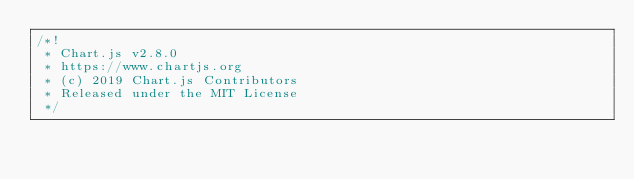<code> <loc_0><loc_0><loc_500><loc_500><_JavaScript_>/*!
 * Chart.js v2.8.0
 * https://www.chartjs.org
 * (c) 2019 Chart.js Contributors
 * Released under the MIT License
 */</code> 